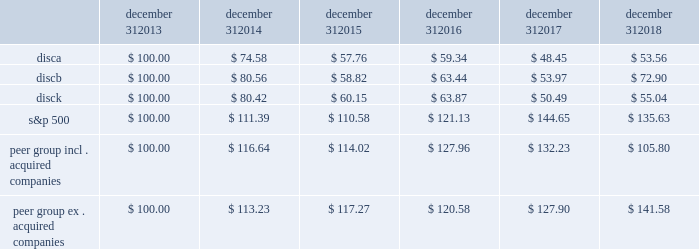Stock performance graph the following graph sets forth the cumulative total shareholder return on our series a common stock , series b common stock and series c common stock as compared with the cumulative total return of the companies listed in the standard and poor 2019s 500 stock index ( 201cs&p 500 index 201d ) and a peer group of companies comprised of cbs corporation class b common stock , scripps network interactive , inc .
( acquired by the company in march 2018 ) , time warner , inc .
( acquired by at&t inc .
In june 2018 ) , twenty-first century fox , inc .
Class a common stock ( news corporation class a common stock prior to june 2013 ) , viacom , inc .
Class b common stock and the walt disney company .
The graph assumes $ 100 originally invested on december 31 , 2013 in each of our series a common stock , series b common stock and series c common stock , the s&p 500 index , and the stock of our peer group companies , including reinvestment of dividends , for the years ended december 31 , 2014 , 2015 , 2016 , 2017 and 2018 .
Two peer companies , scripps networks interactive , inc .
And time warner , inc. , were acquired in 2018 .
The stock performance chart shows the peer group including scripps networks interactive , inc .
And time warner , inc .
And excluding both acquired companies for the entire five year period .
December 31 , december 31 , december 31 , december 31 , december 31 , december 31 .
Equity compensation plan information information regarding securities authorized for issuance under equity compensation plans will be set forth in our definitive proxy statement for our 2019 annual meeting of stockholders under the caption 201csecurities authorized for issuance under equity compensation plans , 201d which is incorporated herein by reference. .
What was the percentage cumulative total shareholder return on discb for the five year period ended december 31 , 2018? 
Computations: ((72.90 - 100) / 100)
Answer: -0.271. 